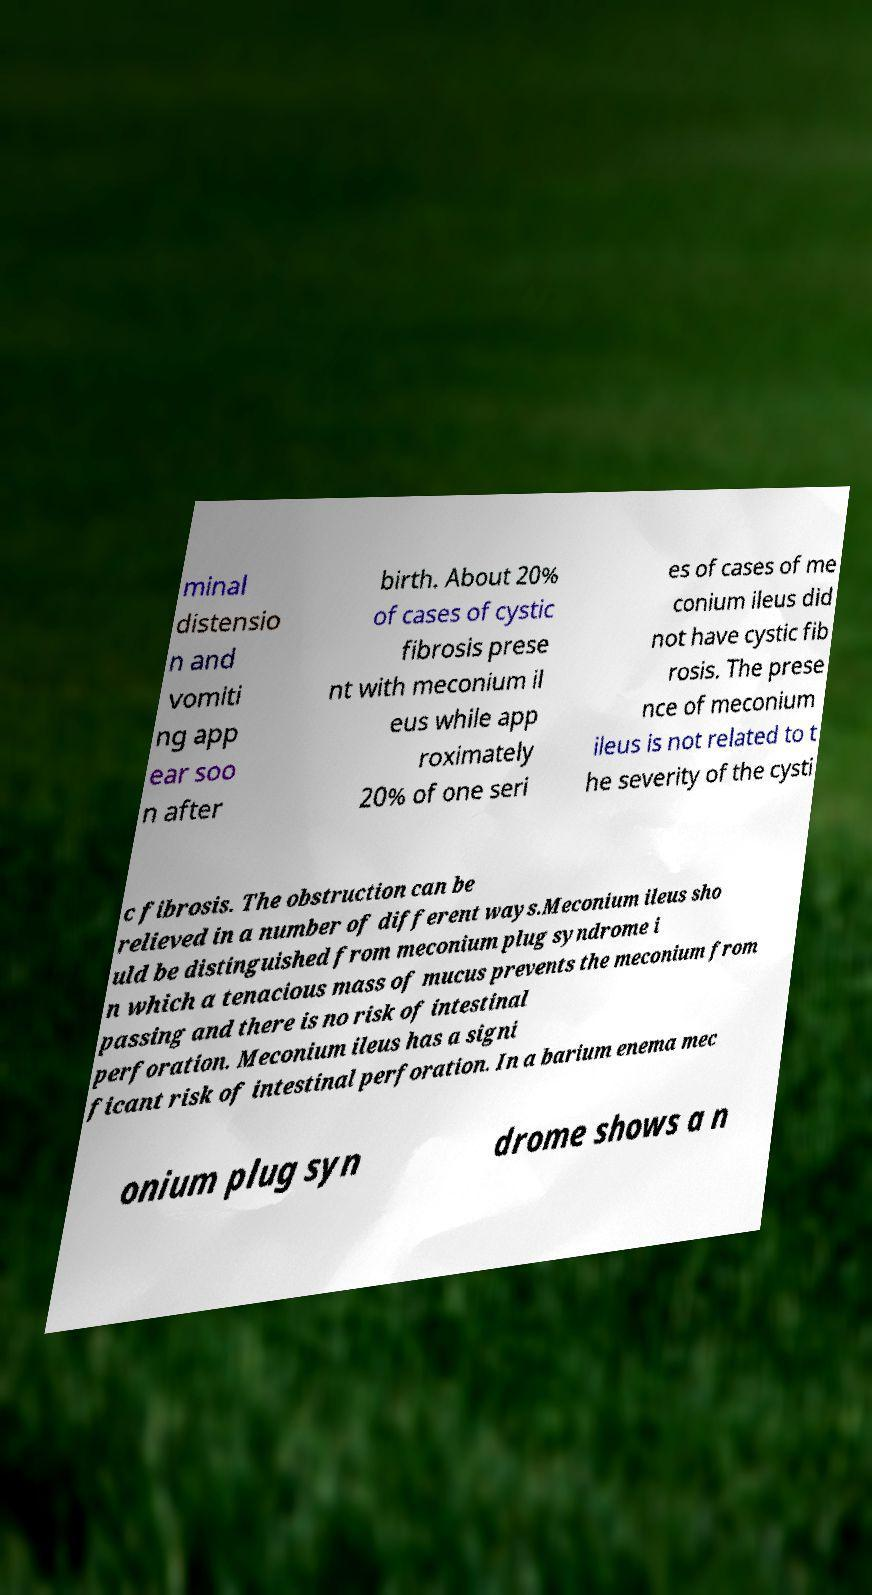Can you accurately transcribe the text from the provided image for me? minal distensio n and vomiti ng app ear soo n after birth. About 20% of cases of cystic fibrosis prese nt with meconium il eus while app roximately 20% of one seri es of cases of me conium ileus did not have cystic fib rosis. The prese nce of meconium ileus is not related to t he severity of the cysti c fibrosis. The obstruction can be relieved in a number of different ways.Meconium ileus sho uld be distinguished from meconium plug syndrome i n which a tenacious mass of mucus prevents the meconium from passing and there is no risk of intestinal perforation. Meconium ileus has a signi ficant risk of intestinal perforation. In a barium enema mec onium plug syn drome shows a n 